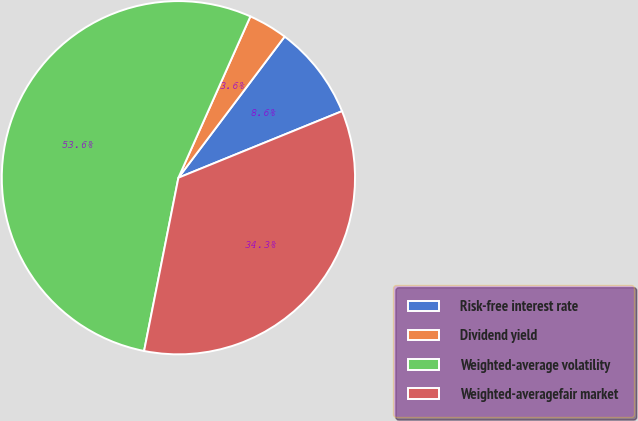Convert chart to OTSL. <chart><loc_0><loc_0><loc_500><loc_500><pie_chart><fcel>Risk-free interest rate<fcel>Dividend yield<fcel>Weighted-average volatility<fcel>Weighted-averagefair market<nl><fcel>8.58%<fcel>3.59%<fcel>53.56%<fcel>34.26%<nl></chart> 